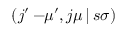<formula> <loc_0><loc_0><loc_500><loc_500>\left ( j ^ { \prime } - \, \mu ^ { \prime } , j \mu \, | \, s \sigma \right )</formula> 